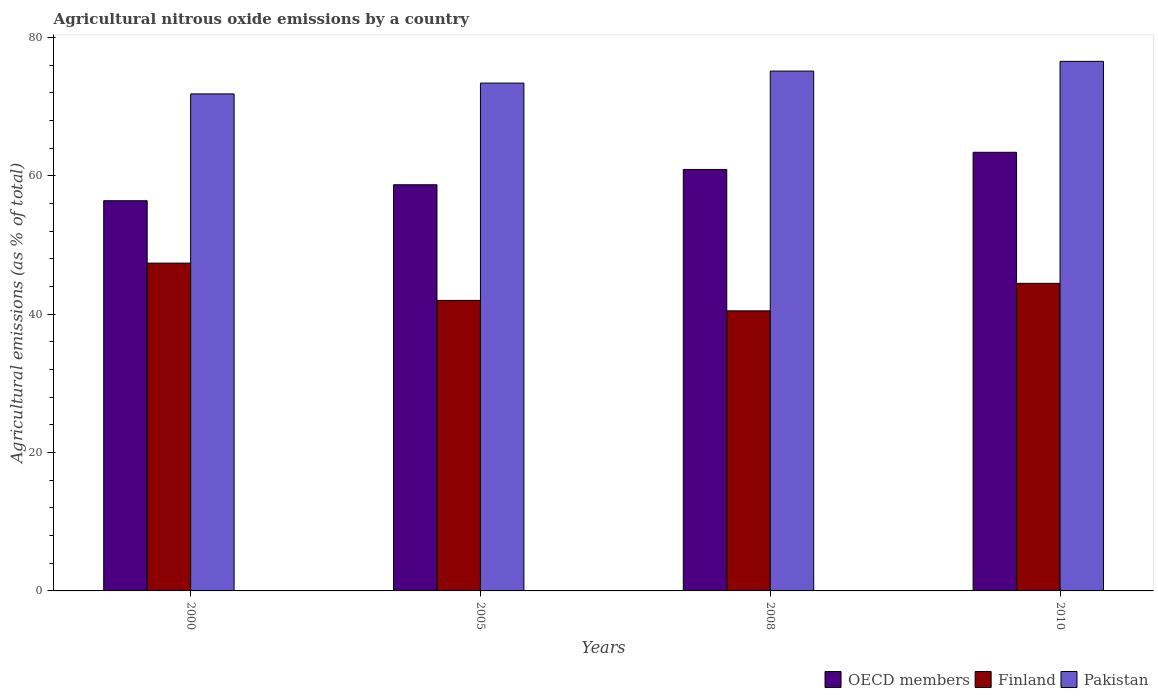How many different coloured bars are there?
Keep it short and to the point. 3. How many groups of bars are there?
Offer a very short reply. 4. Are the number of bars per tick equal to the number of legend labels?
Your answer should be very brief. Yes. How many bars are there on the 2nd tick from the right?
Provide a short and direct response. 3. What is the amount of agricultural nitrous oxide emitted in OECD members in 2000?
Your answer should be very brief. 56.42. Across all years, what is the maximum amount of agricultural nitrous oxide emitted in OECD members?
Provide a succinct answer. 63.42. Across all years, what is the minimum amount of agricultural nitrous oxide emitted in OECD members?
Give a very brief answer. 56.42. In which year was the amount of agricultural nitrous oxide emitted in Pakistan maximum?
Give a very brief answer. 2010. In which year was the amount of agricultural nitrous oxide emitted in OECD members minimum?
Make the answer very short. 2000. What is the total amount of agricultural nitrous oxide emitted in Finland in the graph?
Provide a short and direct response. 174.37. What is the difference between the amount of agricultural nitrous oxide emitted in Finland in 2005 and that in 2010?
Your answer should be compact. -2.47. What is the difference between the amount of agricultural nitrous oxide emitted in Finland in 2000 and the amount of agricultural nitrous oxide emitted in Pakistan in 2010?
Your response must be concise. -29.17. What is the average amount of agricultural nitrous oxide emitted in Pakistan per year?
Give a very brief answer. 74.26. In the year 2008, what is the difference between the amount of agricultural nitrous oxide emitted in Pakistan and amount of agricultural nitrous oxide emitted in Finland?
Offer a very short reply. 34.67. In how many years, is the amount of agricultural nitrous oxide emitted in OECD members greater than 64 %?
Ensure brevity in your answer.  0. What is the ratio of the amount of agricultural nitrous oxide emitted in Pakistan in 2008 to that in 2010?
Offer a terse response. 0.98. What is the difference between the highest and the second highest amount of agricultural nitrous oxide emitted in Finland?
Your answer should be compact. 2.92. What is the difference between the highest and the lowest amount of agricultural nitrous oxide emitted in OECD members?
Offer a very short reply. 7. In how many years, is the amount of agricultural nitrous oxide emitted in OECD members greater than the average amount of agricultural nitrous oxide emitted in OECD members taken over all years?
Keep it short and to the point. 2. What does the 3rd bar from the left in 2000 represents?
Your answer should be compact. Pakistan. Is it the case that in every year, the sum of the amount of agricultural nitrous oxide emitted in Finland and amount of agricultural nitrous oxide emitted in OECD members is greater than the amount of agricultural nitrous oxide emitted in Pakistan?
Offer a terse response. Yes. Are all the bars in the graph horizontal?
Offer a very short reply. No. How many years are there in the graph?
Ensure brevity in your answer.  4. Does the graph contain any zero values?
Keep it short and to the point. No. Does the graph contain grids?
Your answer should be compact. No. How many legend labels are there?
Your answer should be very brief. 3. What is the title of the graph?
Make the answer very short. Agricultural nitrous oxide emissions by a country. What is the label or title of the X-axis?
Offer a very short reply. Years. What is the label or title of the Y-axis?
Give a very brief answer. Agricultural emissions (as % of total). What is the Agricultural emissions (as % of total) of OECD members in 2000?
Keep it short and to the point. 56.42. What is the Agricultural emissions (as % of total) of Finland in 2000?
Your response must be concise. 47.4. What is the Agricultural emissions (as % of total) in Pakistan in 2000?
Provide a short and direct response. 71.86. What is the Agricultural emissions (as % of total) of OECD members in 2005?
Make the answer very short. 58.73. What is the Agricultural emissions (as % of total) in Finland in 2005?
Keep it short and to the point. 42.01. What is the Agricultural emissions (as % of total) of Pakistan in 2005?
Give a very brief answer. 73.43. What is the Agricultural emissions (as % of total) in OECD members in 2008?
Make the answer very short. 60.94. What is the Agricultural emissions (as % of total) of Finland in 2008?
Provide a short and direct response. 40.5. What is the Agricultural emissions (as % of total) of Pakistan in 2008?
Give a very brief answer. 75.17. What is the Agricultural emissions (as % of total) of OECD members in 2010?
Your answer should be compact. 63.42. What is the Agricultural emissions (as % of total) of Finland in 2010?
Your answer should be compact. 44.47. What is the Agricultural emissions (as % of total) in Pakistan in 2010?
Ensure brevity in your answer.  76.57. Across all years, what is the maximum Agricultural emissions (as % of total) of OECD members?
Offer a very short reply. 63.42. Across all years, what is the maximum Agricultural emissions (as % of total) of Finland?
Offer a very short reply. 47.4. Across all years, what is the maximum Agricultural emissions (as % of total) in Pakistan?
Provide a succinct answer. 76.57. Across all years, what is the minimum Agricultural emissions (as % of total) of OECD members?
Offer a very short reply. 56.42. Across all years, what is the minimum Agricultural emissions (as % of total) in Finland?
Your answer should be very brief. 40.5. Across all years, what is the minimum Agricultural emissions (as % of total) in Pakistan?
Provide a succinct answer. 71.86. What is the total Agricultural emissions (as % of total) of OECD members in the graph?
Offer a very short reply. 239.51. What is the total Agricultural emissions (as % of total) in Finland in the graph?
Give a very brief answer. 174.37. What is the total Agricultural emissions (as % of total) in Pakistan in the graph?
Provide a short and direct response. 297.03. What is the difference between the Agricultural emissions (as % of total) of OECD members in 2000 and that in 2005?
Offer a terse response. -2.31. What is the difference between the Agricultural emissions (as % of total) of Finland in 2000 and that in 2005?
Your answer should be compact. 5.39. What is the difference between the Agricultural emissions (as % of total) of Pakistan in 2000 and that in 2005?
Offer a very short reply. -1.56. What is the difference between the Agricultural emissions (as % of total) of OECD members in 2000 and that in 2008?
Offer a very short reply. -4.52. What is the difference between the Agricultural emissions (as % of total) in Finland in 2000 and that in 2008?
Your response must be concise. 6.9. What is the difference between the Agricultural emissions (as % of total) of Pakistan in 2000 and that in 2008?
Your response must be concise. -3.3. What is the difference between the Agricultural emissions (as % of total) in OECD members in 2000 and that in 2010?
Keep it short and to the point. -7. What is the difference between the Agricultural emissions (as % of total) of Finland in 2000 and that in 2010?
Give a very brief answer. 2.92. What is the difference between the Agricultural emissions (as % of total) in Pakistan in 2000 and that in 2010?
Your response must be concise. -4.71. What is the difference between the Agricultural emissions (as % of total) in OECD members in 2005 and that in 2008?
Offer a terse response. -2.21. What is the difference between the Agricultural emissions (as % of total) in Finland in 2005 and that in 2008?
Offer a terse response. 1.51. What is the difference between the Agricultural emissions (as % of total) in Pakistan in 2005 and that in 2008?
Keep it short and to the point. -1.74. What is the difference between the Agricultural emissions (as % of total) of OECD members in 2005 and that in 2010?
Make the answer very short. -4.69. What is the difference between the Agricultural emissions (as % of total) of Finland in 2005 and that in 2010?
Offer a very short reply. -2.47. What is the difference between the Agricultural emissions (as % of total) in Pakistan in 2005 and that in 2010?
Keep it short and to the point. -3.14. What is the difference between the Agricultural emissions (as % of total) of OECD members in 2008 and that in 2010?
Offer a terse response. -2.48. What is the difference between the Agricultural emissions (as % of total) in Finland in 2008 and that in 2010?
Give a very brief answer. -3.98. What is the difference between the Agricultural emissions (as % of total) of Pakistan in 2008 and that in 2010?
Your answer should be compact. -1.4. What is the difference between the Agricultural emissions (as % of total) in OECD members in 2000 and the Agricultural emissions (as % of total) in Finland in 2005?
Your response must be concise. 14.41. What is the difference between the Agricultural emissions (as % of total) in OECD members in 2000 and the Agricultural emissions (as % of total) in Pakistan in 2005?
Offer a terse response. -17.01. What is the difference between the Agricultural emissions (as % of total) in Finland in 2000 and the Agricultural emissions (as % of total) in Pakistan in 2005?
Keep it short and to the point. -26.03. What is the difference between the Agricultural emissions (as % of total) in OECD members in 2000 and the Agricultural emissions (as % of total) in Finland in 2008?
Keep it short and to the point. 15.92. What is the difference between the Agricultural emissions (as % of total) of OECD members in 2000 and the Agricultural emissions (as % of total) of Pakistan in 2008?
Ensure brevity in your answer.  -18.75. What is the difference between the Agricultural emissions (as % of total) of Finland in 2000 and the Agricultural emissions (as % of total) of Pakistan in 2008?
Give a very brief answer. -27.77. What is the difference between the Agricultural emissions (as % of total) of OECD members in 2000 and the Agricultural emissions (as % of total) of Finland in 2010?
Provide a short and direct response. 11.95. What is the difference between the Agricultural emissions (as % of total) of OECD members in 2000 and the Agricultural emissions (as % of total) of Pakistan in 2010?
Make the answer very short. -20.15. What is the difference between the Agricultural emissions (as % of total) of Finland in 2000 and the Agricultural emissions (as % of total) of Pakistan in 2010?
Offer a very short reply. -29.17. What is the difference between the Agricultural emissions (as % of total) of OECD members in 2005 and the Agricultural emissions (as % of total) of Finland in 2008?
Offer a terse response. 18.23. What is the difference between the Agricultural emissions (as % of total) in OECD members in 2005 and the Agricultural emissions (as % of total) in Pakistan in 2008?
Give a very brief answer. -16.44. What is the difference between the Agricultural emissions (as % of total) in Finland in 2005 and the Agricultural emissions (as % of total) in Pakistan in 2008?
Your answer should be very brief. -33.16. What is the difference between the Agricultural emissions (as % of total) of OECD members in 2005 and the Agricultural emissions (as % of total) of Finland in 2010?
Your response must be concise. 14.25. What is the difference between the Agricultural emissions (as % of total) in OECD members in 2005 and the Agricultural emissions (as % of total) in Pakistan in 2010?
Ensure brevity in your answer.  -17.84. What is the difference between the Agricultural emissions (as % of total) of Finland in 2005 and the Agricultural emissions (as % of total) of Pakistan in 2010?
Offer a terse response. -34.56. What is the difference between the Agricultural emissions (as % of total) of OECD members in 2008 and the Agricultural emissions (as % of total) of Finland in 2010?
Offer a terse response. 16.47. What is the difference between the Agricultural emissions (as % of total) of OECD members in 2008 and the Agricultural emissions (as % of total) of Pakistan in 2010?
Your response must be concise. -15.63. What is the difference between the Agricultural emissions (as % of total) in Finland in 2008 and the Agricultural emissions (as % of total) in Pakistan in 2010?
Offer a terse response. -36.07. What is the average Agricultural emissions (as % of total) in OECD members per year?
Ensure brevity in your answer.  59.88. What is the average Agricultural emissions (as % of total) in Finland per year?
Your answer should be compact. 43.59. What is the average Agricultural emissions (as % of total) in Pakistan per year?
Offer a very short reply. 74.26. In the year 2000, what is the difference between the Agricultural emissions (as % of total) in OECD members and Agricultural emissions (as % of total) in Finland?
Your answer should be compact. 9.02. In the year 2000, what is the difference between the Agricultural emissions (as % of total) in OECD members and Agricultural emissions (as % of total) in Pakistan?
Provide a succinct answer. -15.45. In the year 2000, what is the difference between the Agricultural emissions (as % of total) of Finland and Agricultural emissions (as % of total) of Pakistan?
Your answer should be very brief. -24.47. In the year 2005, what is the difference between the Agricultural emissions (as % of total) in OECD members and Agricultural emissions (as % of total) in Finland?
Provide a succinct answer. 16.72. In the year 2005, what is the difference between the Agricultural emissions (as % of total) in OECD members and Agricultural emissions (as % of total) in Pakistan?
Provide a succinct answer. -14.7. In the year 2005, what is the difference between the Agricultural emissions (as % of total) in Finland and Agricultural emissions (as % of total) in Pakistan?
Provide a short and direct response. -31.42. In the year 2008, what is the difference between the Agricultural emissions (as % of total) in OECD members and Agricultural emissions (as % of total) in Finland?
Your answer should be very brief. 20.44. In the year 2008, what is the difference between the Agricultural emissions (as % of total) of OECD members and Agricultural emissions (as % of total) of Pakistan?
Offer a very short reply. -14.22. In the year 2008, what is the difference between the Agricultural emissions (as % of total) of Finland and Agricultural emissions (as % of total) of Pakistan?
Your answer should be very brief. -34.67. In the year 2010, what is the difference between the Agricultural emissions (as % of total) of OECD members and Agricultural emissions (as % of total) of Finland?
Provide a short and direct response. 18.95. In the year 2010, what is the difference between the Agricultural emissions (as % of total) of OECD members and Agricultural emissions (as % of total) of Pakistan?
Give a very brief answer. -13.15. In the year 2010, what is the difference between the Agricultural emissions (as % of total) in Finland and Agricultural emissions (as % of total) in Pakistan?
Keep it short and to the point. -32.1. What is the ratio of the Agricultural emissions (as % of total) in OECD members in 2000 to that in 2005?
Your answer should be compact. 0.96. What is the ratio of the Agricultural emissions (as % of total) in Finland in 2000 to that in 2005?
Provide a succinct answer. 1.13. What is the ratio of the Agricultural emissions (as % of total) in Pakistan in 2000 to that in 2005?
Your response must be concise. 0.98. What is the ratio of the Agricultural emissions (as % of total) of OECD members in 2000 to that in 2008?
Provide a succinct answer. 0.93. What is the ratio of the Agricultural emissions (as % of total) of Finland in 2000 to that in 2008?
Ensure brevity in your answer.  1.17. What is the ratio of the Agricultural emissions (as % of total) of Pakistan in 2000 to that in 2008?
Your response must be concise. 0.96. What is the ratio of the Agricultural emissions (as % of total) of OECD members in 2000 to that in 2010?
Keep it short and to the point. 0.89. What is the ratio of the Agricultural emissions (as % of total) in Finland in 2000 to that in 2010?
Give a very brief answer. 1.07. What is the ratio of the Agricultural emissions (as % of total) of Pakistan in 2000 to that in 2010?
Provide a succinct answer. 0.94. What is the ratio of the Agricultural emissions (as % of total) in OECD members in 2005 to that in 2008?
Your answer should be very brief. 0.96. What is the ratio of the Agricultural emissions (as % of total) of Finland in 2005 to that in 2008?
Provide a short and direct response. 1.04. What is the ratio of the Agricultural emissions (as % of total) in Pakistan in 2005 to that in 2008?
Provide a succinct answer. 0.98. What is the ratio of the Agricultural emissions (as % of total) in OECD members in 2005 to that in 2010?
Your response must be concise. 0.93. What is the ratio of the Agricultural emissions (as % of total) of Finland in 2005 to that in 2010?
Offer a very short reply. 0.94. What is the ratio of the Agricultural emissions (as % of total) of OECD members in 2008 to that in 2010?
Your response must be concise. 0.96. What is the ratio of the Agricultural emissions (as % of total) in Finland in 2008 to that in 2010?
Give a very brief answer. 0.91. What is the ratio of the Agricultural emissions (as % of total) of Pakistan in 2008 to that in 2010?
Your answer should be compact. 0.98. What is the difference between the highest and the second highest Agricultural emissions (as % of total) of OECD members?
Offer a very short reply. 2.48. What is the difference between the highest and the second highest Agricultural emissions (as % of total) of Finland?
Provide a succinct answer. 2.92. What is the difference between the highest and the second highest Agricultural emissions (as % of total) in Pakistan?
Offer a terse response. 1.4. What is the difference between the highest and the lowest Agricultural emissions (as % of total) in OECD members?
Provide a short and direct response. 7. What is the difference between the highest and the lowest Agricultural emissions (as % of total) of Finland?
Give a very brief answer. 6.9. What is the difference between the highest and the lowest Agricultural emissions (as % of total) in Pakistan?
Your answer should be very brief. 4.71. 